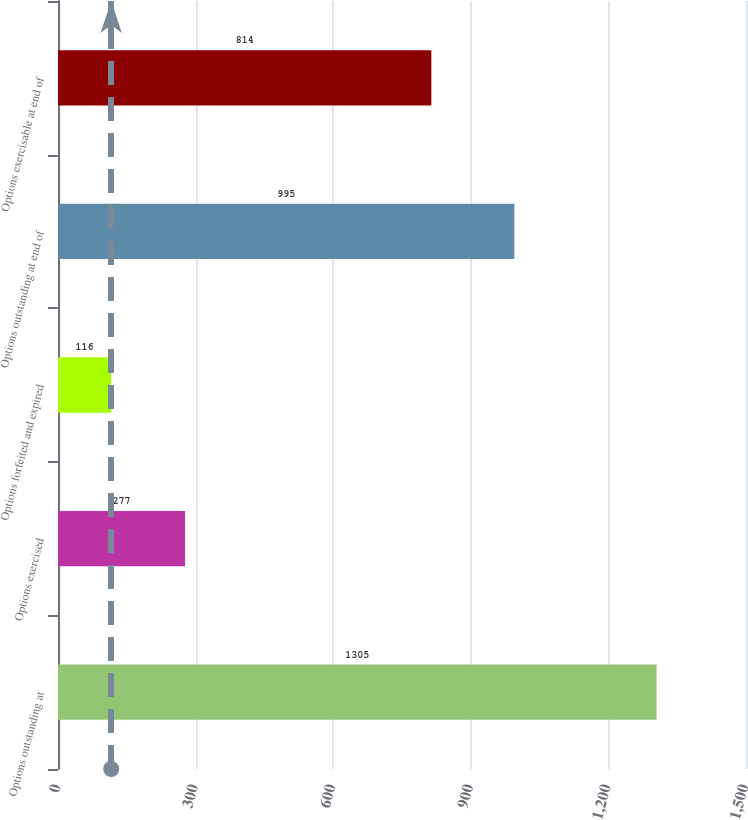Convert chart. <chart><loc_0><loc_0><loc_500><loc_500><bar_chart><fcel>Options outstanding at<fcel>Options exercised<fcel>Options forfeited and expired<fcel>Options outstanding at end of<fcel>Options exercisable at end of<nl><fcel>1305<fcel>277<fcel>116<fcel>995<fcel>814<nl></chart> 